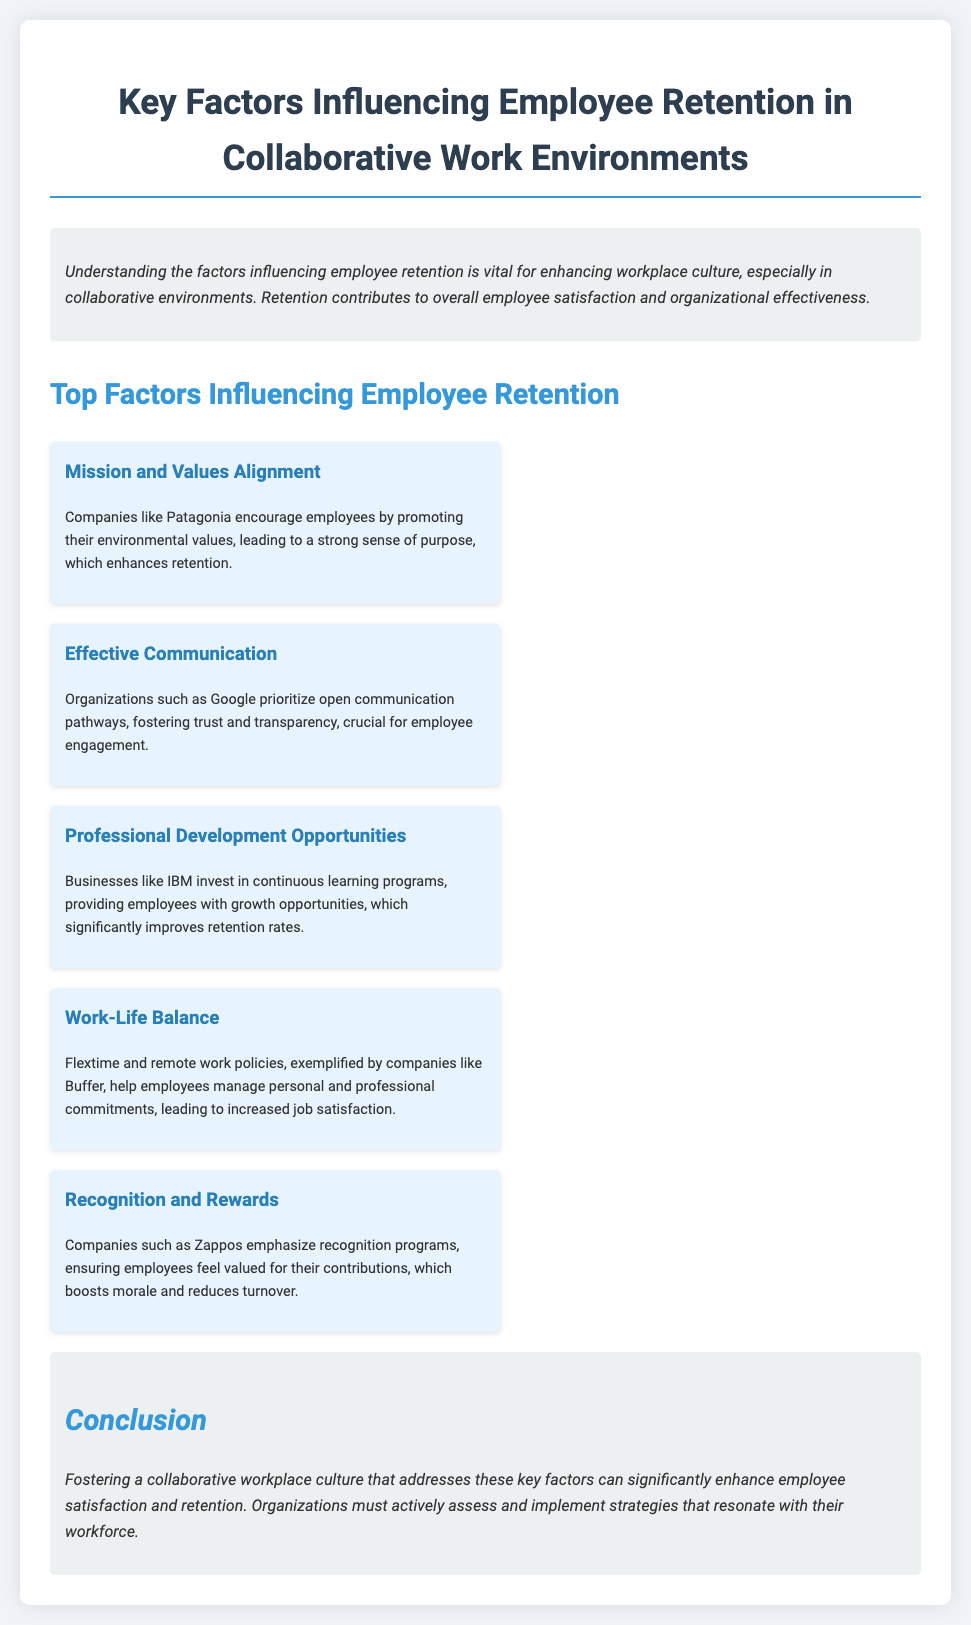what is the title of the document? The title is presented prominently at the top of the document, indicating the main topic covered.
Answer: Key Factors Influencing Employee Retention in Collaborative Work Environments what company is mentioned for its environmental values? The document provides an example of a company that promotes environmental values and enhances employee retention.
Answer: Patagonia which factor involves fostering trust and transparency? This factor emphasizes the importance of communication in creating a positive work environment.
Answer: Effective Communication how does IBM support employee retention? The document states how IBM invests in a specific type of employee development to improve retention.
Answer: Continuous learning programs what is a key policy that Buffer implements to enhance job satisfaction? The document mentions a specific type of policy that companies like Buffer use to help manage employee commitments.
Answer: Flextime and remote work policies which company highlights recognition programs? This company is known for its focus on ensuring employees feel valued through specific programs.
Answer: Zappos what is the overall goal of addressing the key factors? The concluding section summarizes the intended outcome of implementing strategies based on the factors discussed.
Answer: Enhance employee satisfaction and retention how many factors are listed in the document? The document organizes the key factors into a specific number that is highlighted in the section.
Answer: Five 